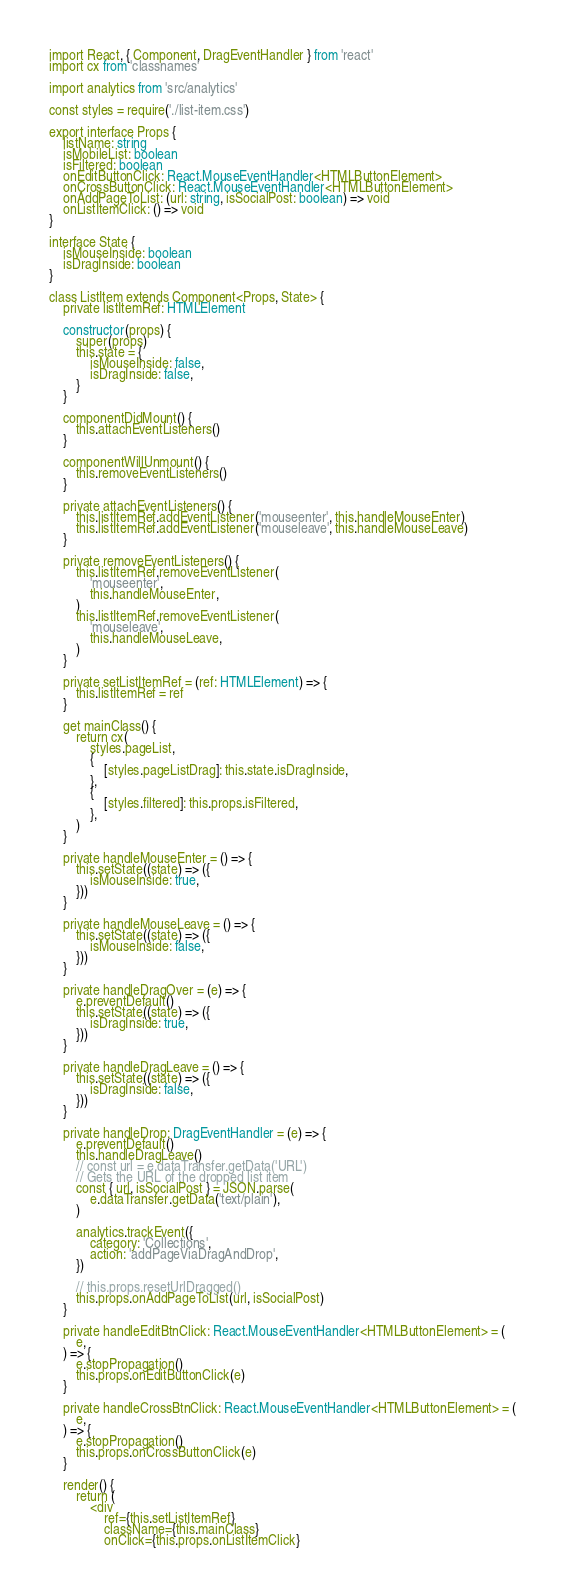<code> <loc_0><loc_0><loc_500><loc_500><_TypeScript_>import React, { Component, DragEventHandler } from 'react'
import cx from 'classnames'

import analytics from 'src/analytics'

const styles = require('./list-item.css')

export interface Props {
    listName: string
    isMobileList: boolean
    isFiltered: boolean
    onEditButtonClick: React.MouseEventHandler<HTMLButtonElement>
    onCrossButtonClick: React.MouseEventHandler<HTMLButtonElement>
    onAddPageToList: (url: string, isSocialPost: boolean) => void
    onListItemClick: () => void
}

interface State {
    isMouseInside: boolean
    isDragInside: boolean
}

class ListItem extends Component<Props, State> {
    private listItemRef: HTMLElement

    constructor(props) {
        super(props)
        this.state = {
            isMouseInside: false,
            isDragInside: false,
        }
    }

    componentDidMount() {
        this.attachEventListeners()
    }

    componentWillUnmount() {
        this.removeEventListeners()
    }

    private attachEventListeners() {
        this.listItemRef.addEventListener('mouseenter', this.handleMouseEnter)
        this.listItemRef.addEventListener('mouseleave', this.handleMouseLeave)
    }

    private removeEventListeners() {
        this.listItemRef.removeEventListener(
            'mouseenter',
            this.handleMouseEnter,
        )
        this.listItemRef.removeEventListener(
            'mouseleave',
            this.handleMouseLeave,
        )
    }

    private setListItemRef = (ref: HTMLElement) => {
        this.listItemRef = ref
    }

    get mainClass() {
        return cx(
            styles.pageList,
            {
                [styles.pageListDrag]: this.state.isDragInside,
            },
            {
                [styles.filtered]: this.props.isFiltered,
            },
        )
    }

    private handleMouseEnter = () => {
        this.setState((state) => ({
            isMouseInside: true,
        }))
    }

    private handleMouseLeave = () => {
        this.setState((state) => ({
            isMouseInside: false,
        }))
    }

    private handleDragOver = (e) => {
        e.preventDefault()
        this.setState((state) => ({
            isDragInside: true,
        }))
    }

    private handleDragLeave = () => {
        this.setState((state) => ({
            isDragInside: false,
        }))
    }

    private handleDrop: DragEventHandler = (e) => {
        e.preventDefault()
        this.handleDragLeave()
        // const url = e.dataTransfer.getData('URL')
        // Gets the URL of the dropped list item
        const { url, isSocialPost } = JSON.parse(
            e.dataTransfer.getData('text/plain'),
        )

        analytics.trackEvent({
            category: 'Collections',
            action: 'addPageViaDragAndDrop',
        })

        // this.props.resetUrlDragged()
        this.props.onAddPageToList(url, isSocialPost)
    }

    private handleEditBtnClick: React.MouseEventHandler<HTMLButtonElement> = (
        e,
    ) => {
        e.stopPropagation()
        this.props.onEditButtonClick(e)
    }

    private handleCrossBtnClick: React.MouseEventHandler<HTMLButtonElement> = (
        e,
    ) => {
        e.stopPropagation()
        this.props.onCrossButtonClick(e)
    }

    render() {
        return (
            <div
                ref={this.setListItemRef}
                className={this.mainClass}
                onClick={this.props.onListItemClick}</code> 